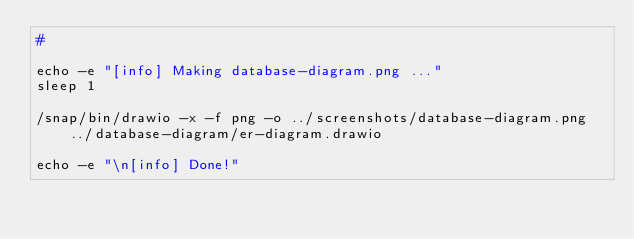<code> <loc_0><loc_0><loc_500><loc_500><_Bash_>#

echo -e "[info] Making database-diagram.png ..."
sleep 1

/snap/bin/drawio -x -f png -o ../screenshots/database-diagram.png ../database-diagram/er-diagram.drawio

echo -e "\n[info] Done!"</code> 